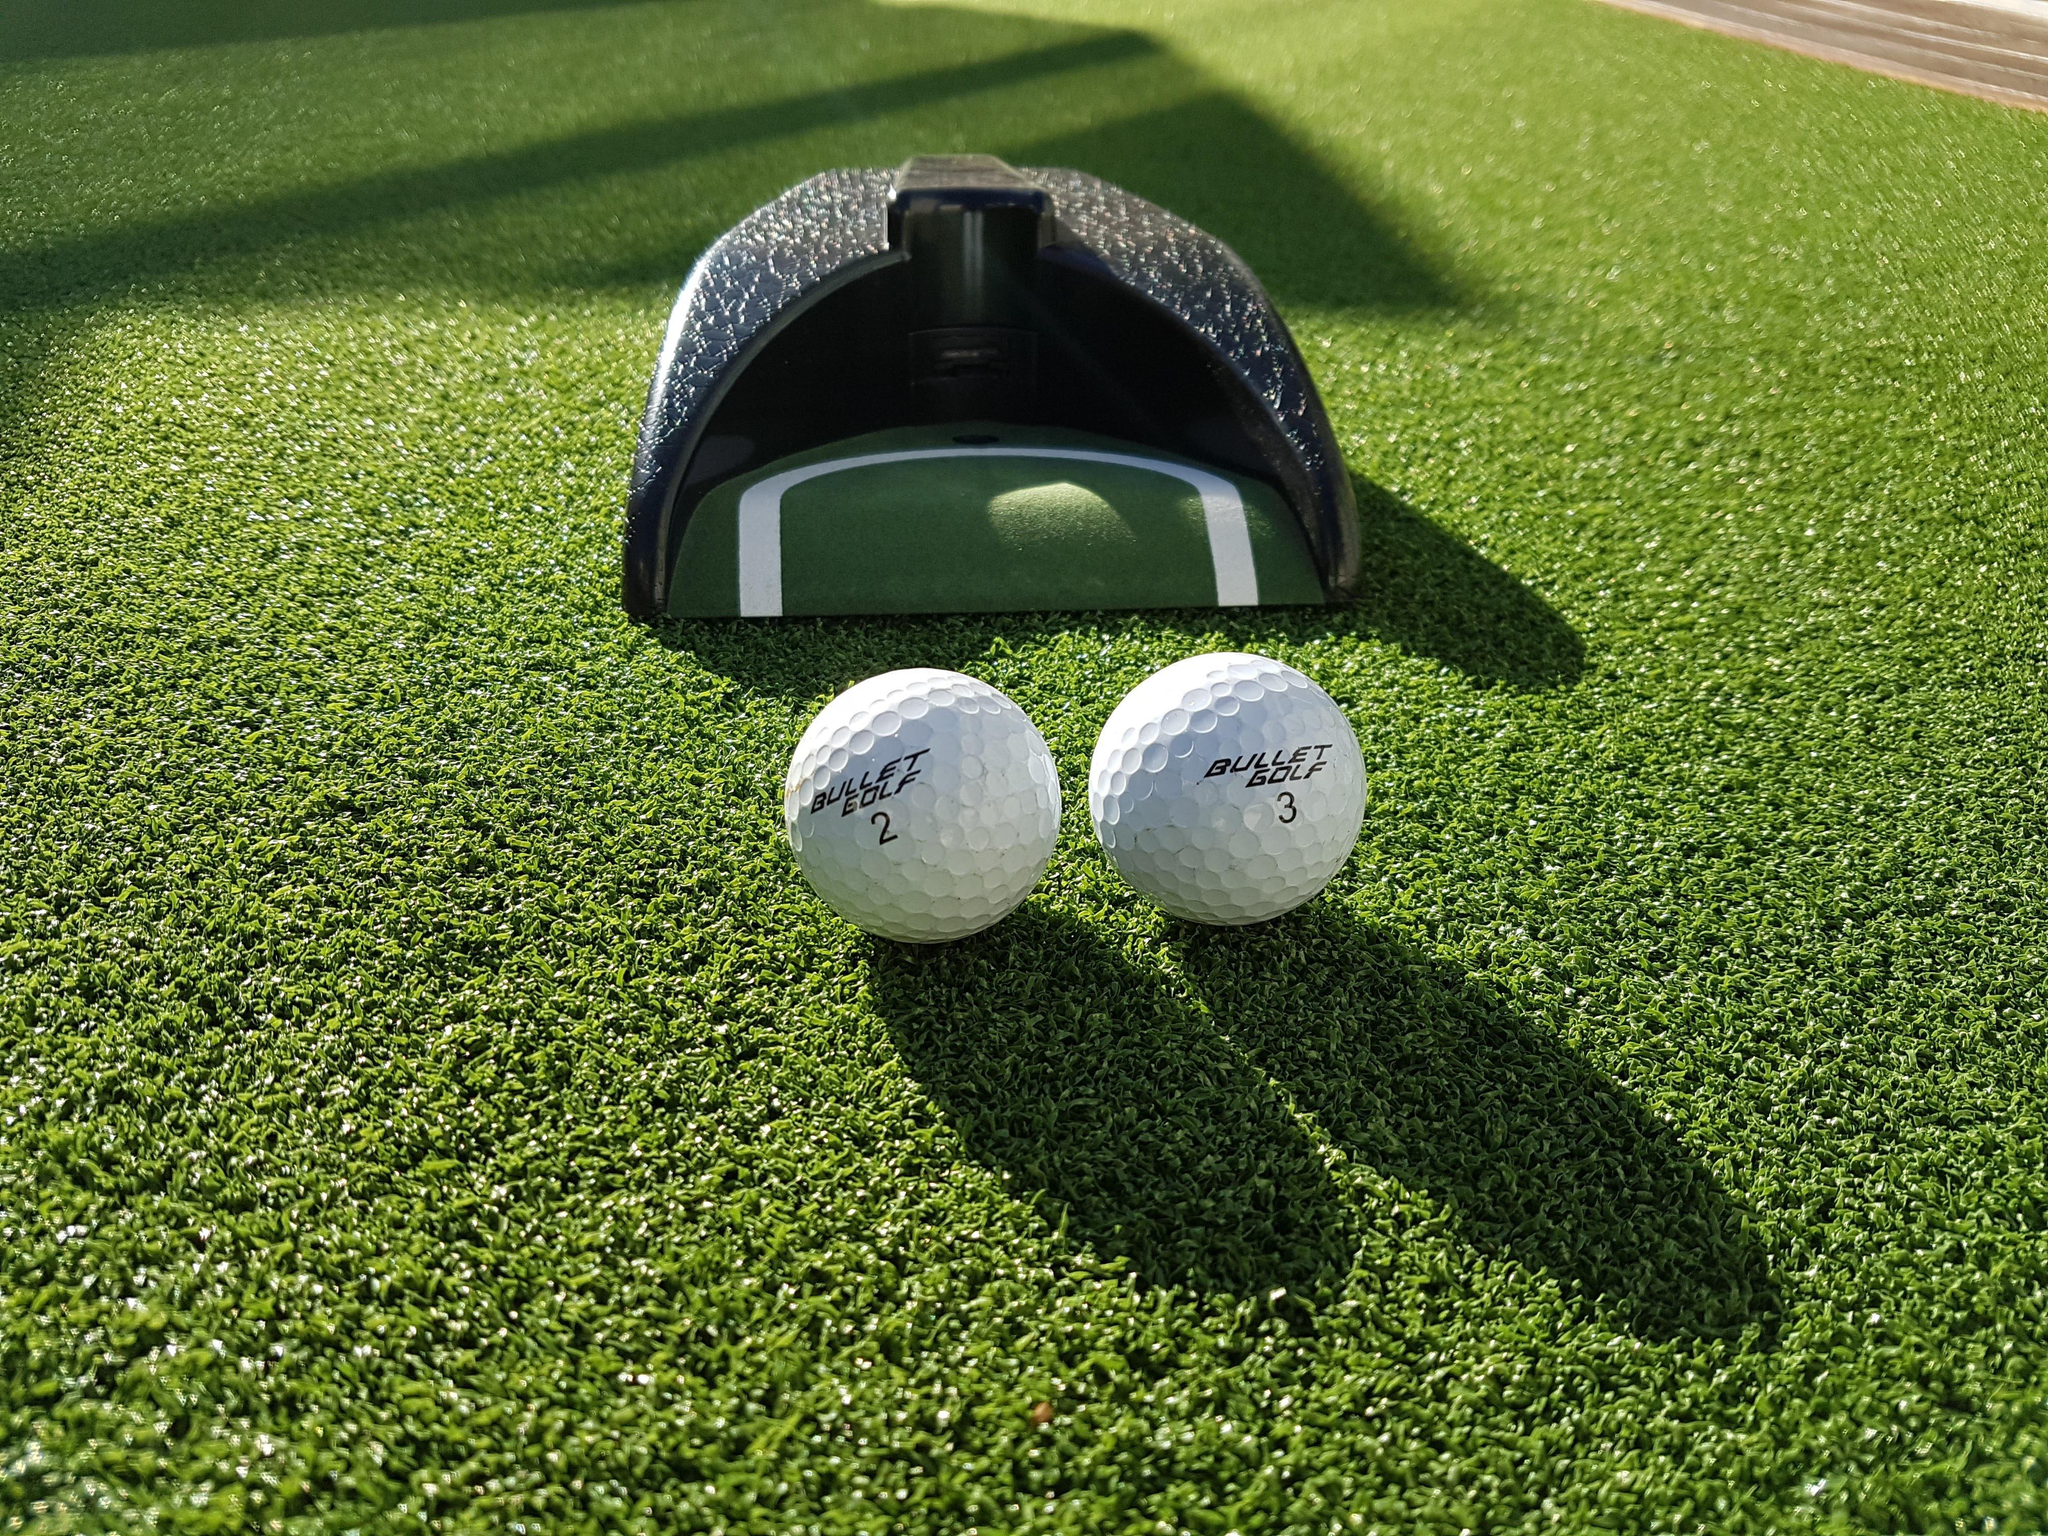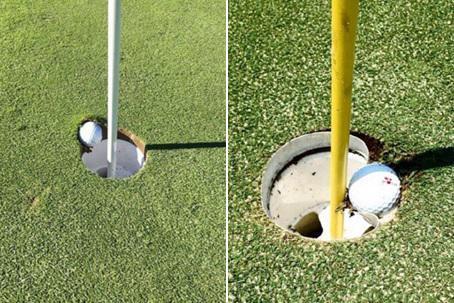The first image is the image on the left, the second image is the image on the right. For the images displayed, is the sentence "two balls are placed side by side in front of a dome type cover" factually correct? Answer yes or no. Yes. 